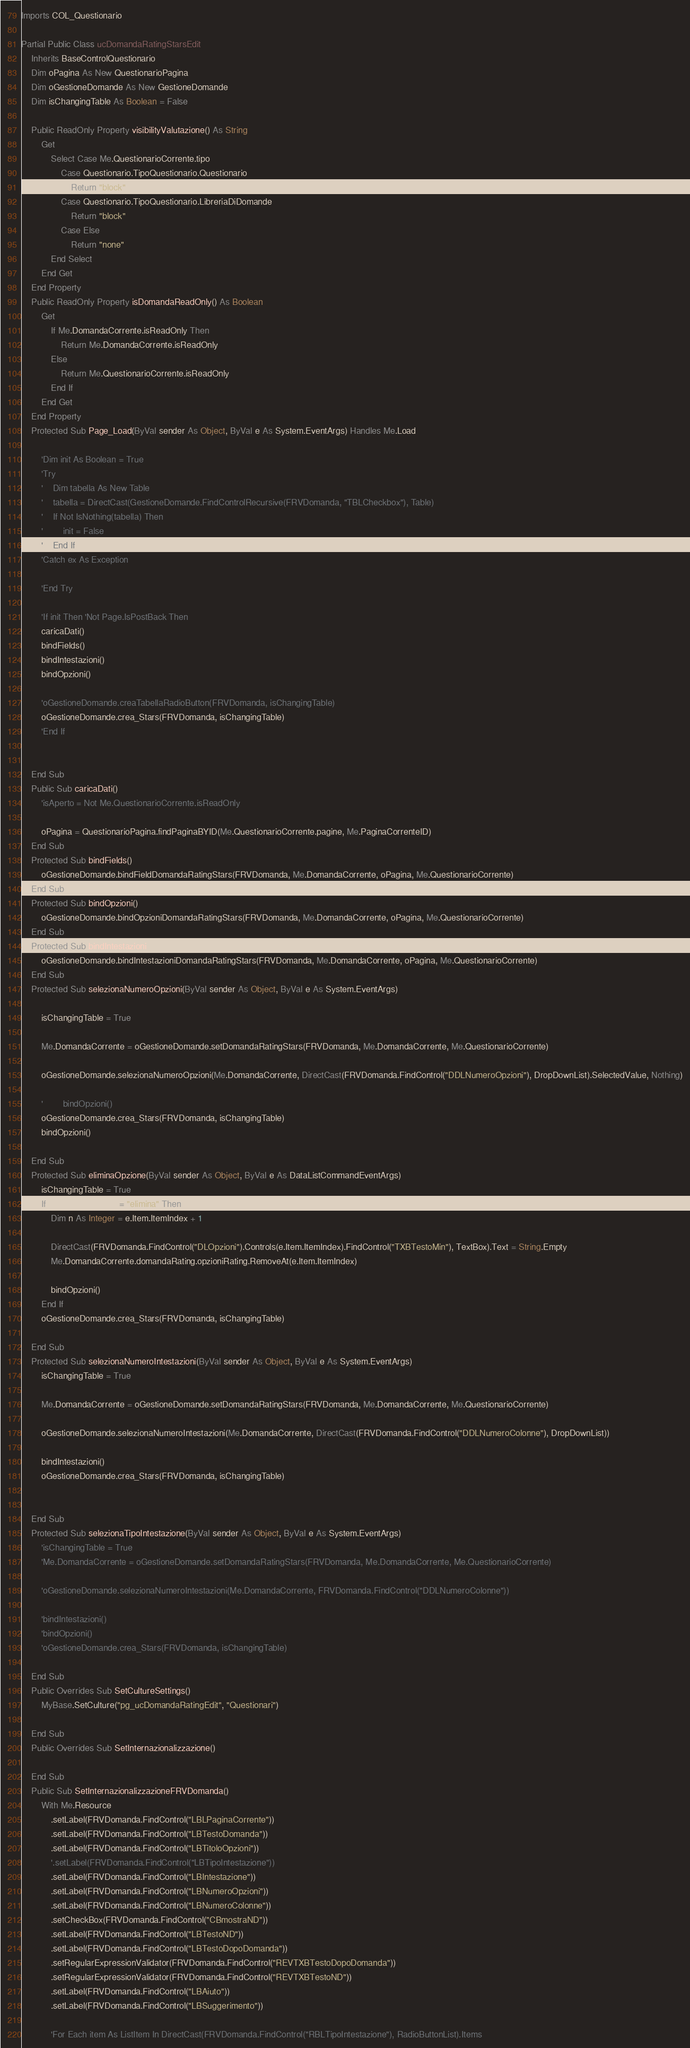Convert code to text. <code><loc_0><loc_0><loc_500><loc_500><_VisualBasic_>Imports COL_Questionario

Partial Public Class ucDomandaRatingStarsEdit
    Inherits BaseControlQuestionario
    Dim oPagina As New QuestionarioPagina
    Dim oGestioneDomande As New GestioneDomande
    Dim isChangingTable As Boolean = False

    Public ReadOnly Property visibilityValutazione() As String
        Get
            Select Case Me.QuestionarioCorrente.tipo
                Case Questionario.TipoQuestionario.Questionario
                    Return "block"
                Case Questionario.TipoQuestionario.LibreriaDiDomande
                    Return "block"
                Case Else
                    Return "none"
            End Select
        End Get
    End Property
    Public ReadOnly Property isDomandaReadOnly() As Boolean
        Get
            If Me.DomandaCorrente.isReadOnly Then
                Return Me.DomandaCorrente.isReadOnly
            Else
                Return Me.QuestionarioCorrente.isReadOnly
            End If
        End Get
    End Property
    Protected Sub Page_Load(ByVal sender As Object, ByVal e As System.EventArgs) Handles Me.Load

        'Dim init As Boolean = True
        'Try
        '    Dim tabella As New Table
        '    tabella = DirectCast(GestioneDomande.FindControlRecursive(FRVDomanda, "TBLCheckbox"), Table)
        '    If Not IsNothing(tabella) Then
        '        init = False
        '    End If
        'Catch ex As Exception

        'End Try

        'If init Then 'Not Page.IsPostBack Then
        caricaDati()
        bindFields()
        bindIntestazioni()
        bindOpzioni()

        'oGestioneDomande.creaTabellaRadioButton(FRVDomanda, isChangingTable)
        oGestioneDomande.crea_Stars(FRVDomanda, isChangingTable)
        'End If


    End Sub
    Public Sub caricaDati()
        'isAperto = Not Me.QuestionarioCorrente.isReadOnly

        oPagina = QuestionarioPagina.findPaginaBYID(Me.QuestionarioCorrente.pagine, Me.PaginaCorrenteID)
    End Sub
    Protected Sub bindFields()
        oGestioneDomande.bindFieldDomandaRatingStars(FRVDomanda, Me.DomandaCorrente, oPagina, Me.QuestionarioCorrente)
    End Sub
    Protected Sub bindOpzioni()
        oGestioneDomande.bindOpzioniDomandaRatingStars(FRVDomanda, Me.DomandaCorrente, oPagina, Me.QuestionarioCorrente)
    End Sub
    Protected Sub bindIntestazioni()
        oGestioneDomande.bindIntestazioniDomandaRatingStars(FRVDomanda, Me.DomandaCorrente, oPagina, Me.QuestionarioCorrente)
    End Sub
    Protected Sub selezionaNumeroOpzioni(ByVal sender As Object, ByVal e As System.EventArgs)

        isChangingTable = True

        Me.DomandaCorrente = oGestioneDomande.setDomandaRatingStars(FRVDomanda, Me.DomandaCorrente, Me.QuestionarioCorrente)

        oGestioneDomande.selezionaNumeroOpzioni(Me.DomandaCorrente, DirectCast(FRVDomanda.FindControl("DDLNumeroOpzioni"), DropDownList).SelectedValue, Nothing)

        '        bindOpzioni()
        oGestioneDomande.crea_Stars(FRVDomanda, isChangingTable)
        bindOpzioni()

    End Sub
    Protected Sub eliminaOpzione(ByVal sender As Object, ByVal e As DataListCommandEventArgs)
        isChangingTable = True
        If e.CommandName = "elimina" Then
            Dim n As Integer = e.Item.ItemIndex + 1

            DirectCast(FRVDomanda.FindControl("DLOpzioni").Controls(e.Item.ItemIndex).FindControl("TXBTestoMin"), TextBox).Text = String.Empty
            Me.DomandaCorrente.domandaRating.opzioniRating.RemoveAt(e.Item.ItemIndex)

            bindOpzioni()
        End If
        oGestioneDomande.crea_Stars(FRVDomanda, isChangingTable)

    End Sub
    Protected Sub selezionaNumeroIntestazioni(ByVal sender As Object, ByVal e As System.EventArgs)
        isChangingTable = True

        Me.DomandaCorrente = oGestioneDomande.setDomandaRatingStars(FRVDomanda, Me.DomandaCorrente, Me.QuestionarioCorrente)

        oGestioneDomande.selezionaNumeroIntestazioni(Me.DomandaCorrente, DirectCast(FRVDomanda.FindControl("DDLNumeroColonne"), DropDownList))

        bindIntestazioni()
        oGestioneDomande.crea_Stars(FRVDomanda, isChangingTable)


    End Sub
    Protected Sub selezionaTipoIntestazione(ByVal sender As Object, ByVal e As System.EventArgs)
        'isChangingTable = True
        'Me.DomandaCorrente = oGestioneDomande.setDomandaRatingStars(FRVDomanda, Me.DomandaCorrente, Me.QuestionarioCorrente)

        'oGestioneDomande.selezionaNumeroIntestazioni(Me.DomandaCorrente, FRVDomanda.FindControl("DDLNumeroColonne"))

        'bindIntestazioni()
        'bindOpzioni()
        'oGestioneDomande.crea_Stars(FRVDomanda, isChangingTable)

    End Sub
    Public Overrides Sub SetCultureSettings()
        MyBase.SetCulture("pg_ucDomandaRatingEdit", "Questionari")

    End Sub
    Public Overrides Sub SetInternazionalizzazione()

    End Sub
    Public Sub SetInternazionalizzazioneFRVDomanda()
        With Me.Resource
            .setLabel(FRVDomanda.FindControl("LBLPaginaCorrente"))
            .setLabel(FRVDomanda.FindControl("LBTestoDomanda"))
            .setLabel(FRVDomanda.FindControl("LBTitoloOpzioni"))
            '.setLabel(FRVDomanda.FindControl("LBTipoIntestazione"))
            .setLabel(FRVDomanda.FindControl("LBIntestazione"))
            .setLabel(FRVDomanda.FindControl("LBNumeroOpzioni"))
            .setLabel(FRVDomanda.FindControl("LBNumeroColonne"))
            .setCheckBox(FRVDomanda.FindControl("CBmostraND"))
            .setLabel(FRVDomanda.FindControl("LBTestoND"))
            .setLabel(FRVDomanda.FindControl("LBTestoDopoDomanda"))
            .setRegularExpressionValidator(FRVDomanda.FindControl("REVTXBTestoDopoDomanda"))
            .setRegularExpressionValidator(FRVDomanda.FindControl("REVTXBTestoND"))
            .setLabel(FRVDomanda.FindControl("LBAiuto"))
            .setLabel(FRVDomanda.FindControl("LBSuggerimento"))

            'For Each item As ListItem In DirectCast(FRVDomanda.FindControl("RBLTipoIntestazione"), RadioButtonList).Items</code> 